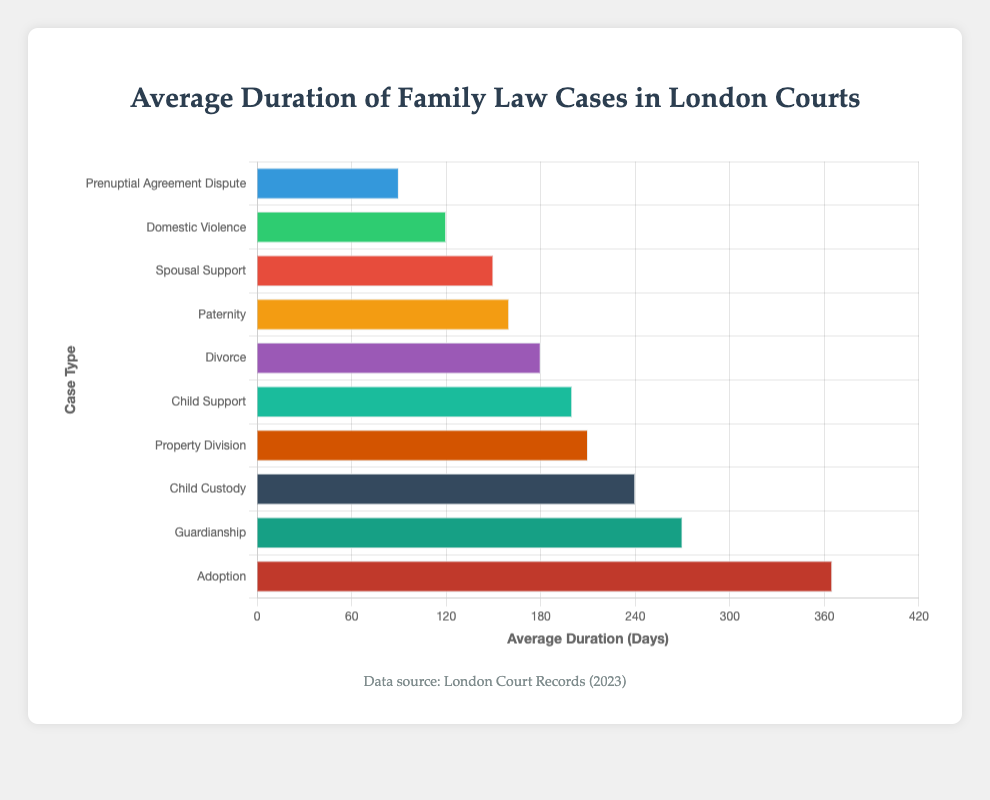Which case type has the longest average duration? By observing the heights of the bars, the "Adoption" case type has the longest bar, thus it has the longest average duration.
Answer: Adoption Which case types have an average duration of less than 150 days? By examining the lengths of the bars, "Prenuptial Agreement Dispute," "Domestic Violence," and "Spousal Support" have average durations shorter than 150 days.
Answer: Prenuptial Agreement Dispute, Domestic Violence, Spousal Support What's the difference in average duration between "Child Custody" and "Child Support" cases? The average duration of "Child Custody" is 240 days and that of "Child Support" is 200 days. The difference is 240 - 200 = 40 days.
Answer: 40 days Which case type has a shorter average duration: "Divorce" or "Paternity"? Comparing the lengths of their bars, "Divorce" has an average duration of 180 days, and "Paternity" has 160 days. So, "Paternity" is shorter.
Answer: Paternity What is the total average duration of "Property Division," "Spousal Support," and "Domestic Violence" cases combined? Adding their average durations: 210 (Property Division) + 150 (Spousal Support) + 120 (Domestic Violence) = 480 days.
Answer: 480 days What is the median average duration of all case types in the figure? Listing the average durations in ascending order: 90, 120, 150, 160, 180, 200, 210, 240, 270, 365. The median is the average of the 5th and 6th values: (180 + 200) / 2 = 190 days.
Answer: 190 days Which case type has the smallest average duration? By observing the heights of the bars, the "Prenuptial Agreement Dispute" case type has the shortest bar, thus it has the smallest average duration.
Answer: Prenuptial Agreement Dispute Are there more case types with an average duration above or below 200 days? There are 4 case types below 200 days ("Prenuptial Agreement Dispute," "Domestic Violence," "Spousal Support," "Paternity") and 6 case types above or equal to 200 days ("Divorce," "Child Support," "Property Division," "Child Custody," "Guardianship," "Adoption").
Answer: Above 